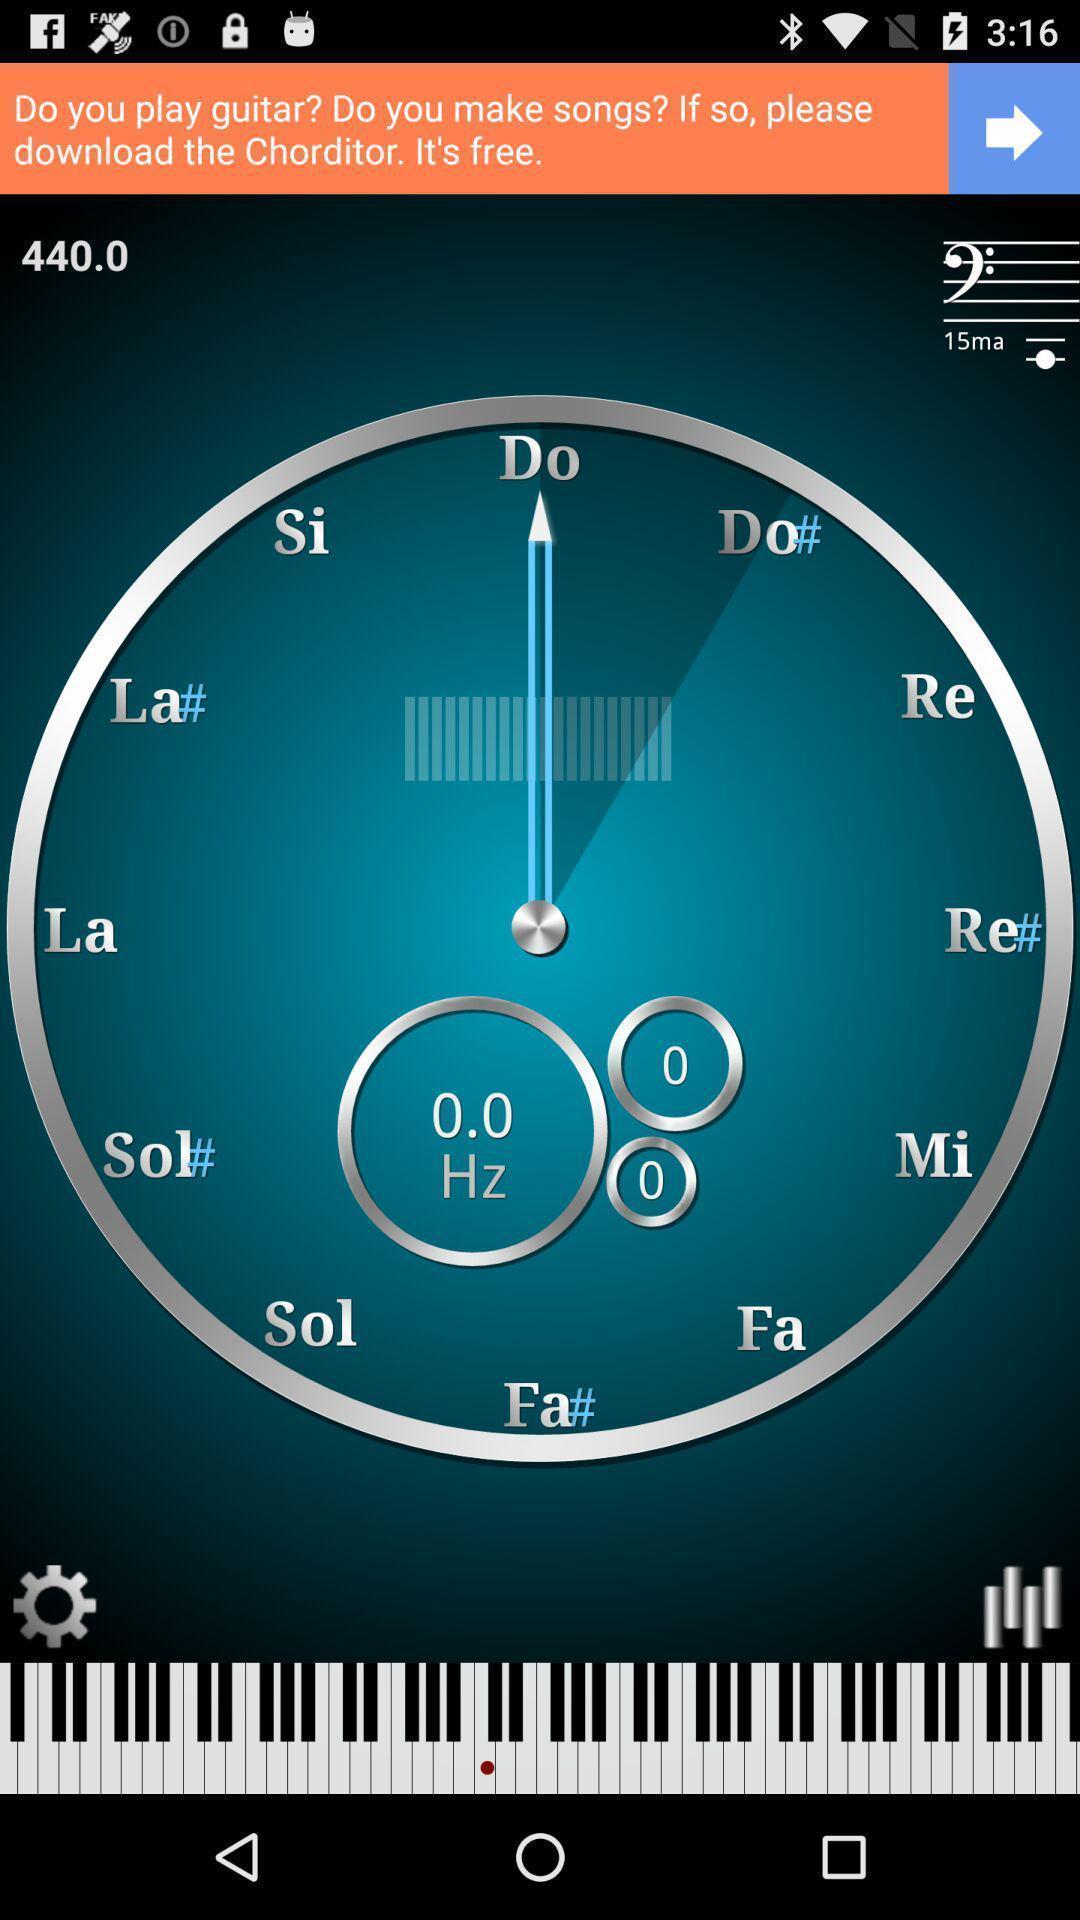Describe the key features of this screenshot. Screen displaying page of an musical application. 